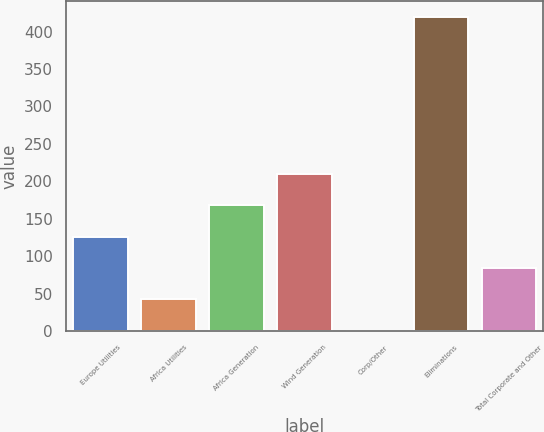Convert chart. <chart><loc_0><loc_0><loc_500><loc_500><bar_chart><fcel>Europe Utilities<fcel>Africa Utilities<fcel>Africa Generation<fcel>Wind Generation<fcel>Corp/Other<fcel>Eliminations<fcel>Total Corporate and Other<nl><fcel>126.3<fcel>42.38<fcel>168.26<fcel>210.22<fcel>0.42<fcel>420<fcel>84.34<nl></chart> 